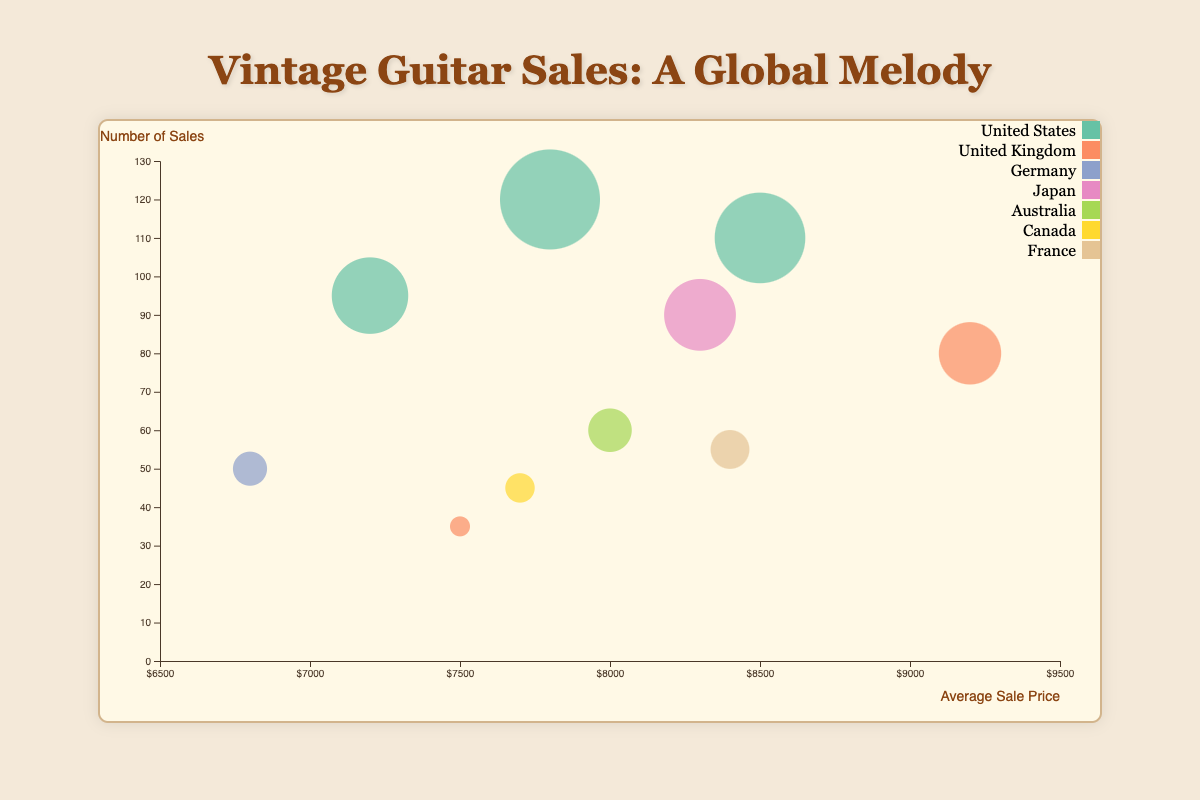What is the average sale price in Los Angeles? The bubble for Los Angeles is located at the position corresponding to an average sale price on the x-axis, which is $8500.
Answer: $8500 Which city has the highest average sale price? To find the highest average sale price, look for the bubble that is furthest to the right on the x-axis. London with $9200 is furthest right.
Answer: London How many sales were made in Nashville? Nashville’s bubble’s position on the y-axis shows the number of sales, which is at 120.
Answer: 120 What is the color representing cities in the United States? By analyzing the legend, the color representing cities in the United States needs to be identified. The color for the United States is used for multiple cities like Nashville and Austin.
Answer: Check the legend Which city has the largest number of sales in Germany? Germany's bubbles include Berlin, displayed as the region with bubbles locating at the 'Germany' position in the legend, and Berlin's size/bubble representing sale count of 50.
Answer: Berlin Compare the average sale price between Tokyo and Sydney. Tokyo’s average sale price is shown at $8300, while Sydney's is at $8000 by their bubbles' x-axis positions. Tokyo has a higher average sale price than Sydney.
Answer: Tokyo What is the minimum number of sales in the United Kingdom? The bubbles representing the United Kingdom are London and Liverpool. Liverpool has 35 sales (smaller sized) compared to London’s 80.
Answer: 35 Is the bubble for Paris larger or smaller than the bubble for Toronto? The bubble size corresponds to the number of sales; Paris has 55 whereas Toronto has 45 sales, so Paris's bubble is larger.
Answer: Larger How does the average sale price in Berlin compare to Austin? Berlin’s bubble on the x-axis is around $6800, whereas Austin's is around $7200. Austin has a higher average sale price than Berlin.
Answer: Berlin lower Which region has the most cities represented in the chart? By counting the cities per region from the legend and data, the United States has the most cities represented (Nashville, Austin, and Los Angeles).
Answer: United States 